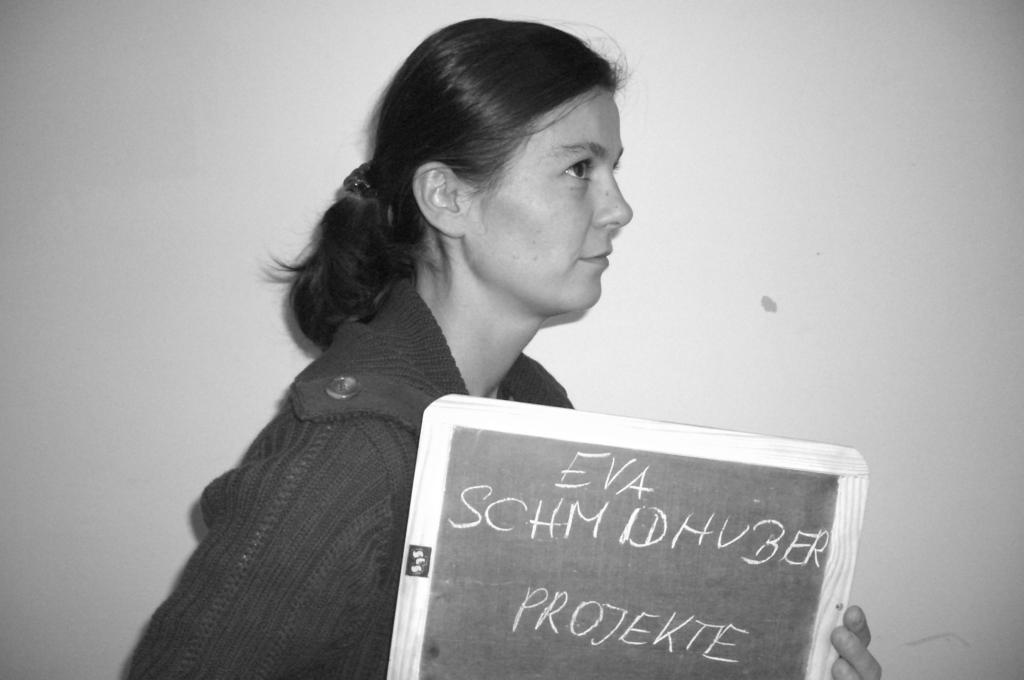What is the color scheme of the image? The image is black and white. Who is present in the image? There is a woman in the image. What is the woman wearing? The woman is wearing a hoodie. What object is the woman holding in her hand? The woman is holding a slate in her hand. What can be seen on the slate? There is writing on the slate. How many women are playing with the star in the image? There is no star present in the image, and no women are playing with it. 